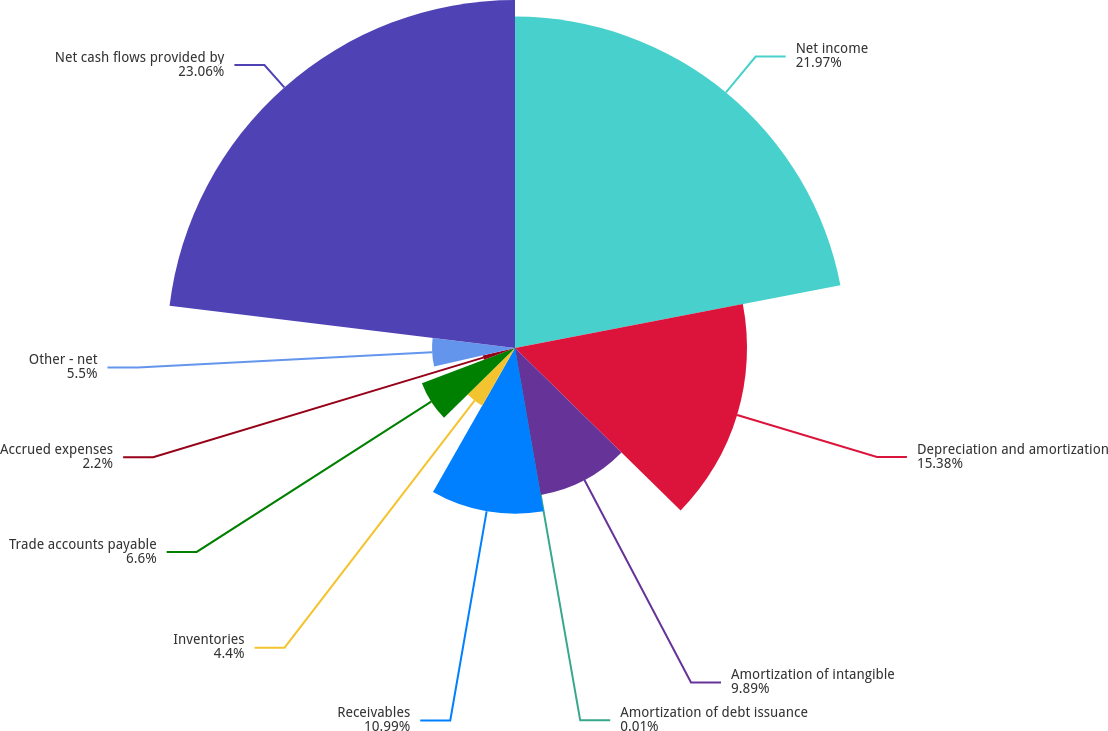Convert chart. <chart><loc_0><loc_0><loc_500><loc_500><pie_chart><fcel>Net income<fcel>Depreciation and amortization<fcel>Amortization of intangible<fcel>Amortization of debt issuance<fcel>Receivables<fcel>Inventories<fcel>Trade accounts payable<fcel>Accrued expenses<fcel>Other - net<fcel>Net cash flows provided by<nl><fcel>21.97%<fcel>15.38%<fcel>9.89%<fcel>0.01%<fcel>10.99%<fcel>4.4%<fcel>6.6%<fcel>2.2%<fcel>5.5%<fcel>23.07%<nl></chart> 